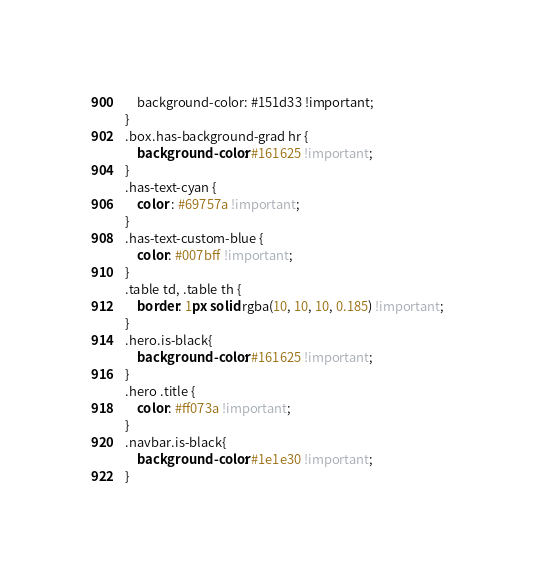<code> <loc_0><loc_0><loc_500><loc_500><_CSS_>    background-color: #151d33 !important;
}
.box.has-background-grad hr {
    background-color: #161625 !important;
}
.has-text-cyan {
    color : #69757a !important;
}
.has-text-custom-blue {
    color: #007bff !important;
}
.table td, .table th {
    border: 1px solid rgba(10, 10, 10, 0.185) !important;
}
.hero.is-black{
    background-color: #161625 !important;
}
.hero .title {
    color: #ff073a !important;
}
.navbar.is-black{
    background-color: #1e1e30 !important;
}</code> 